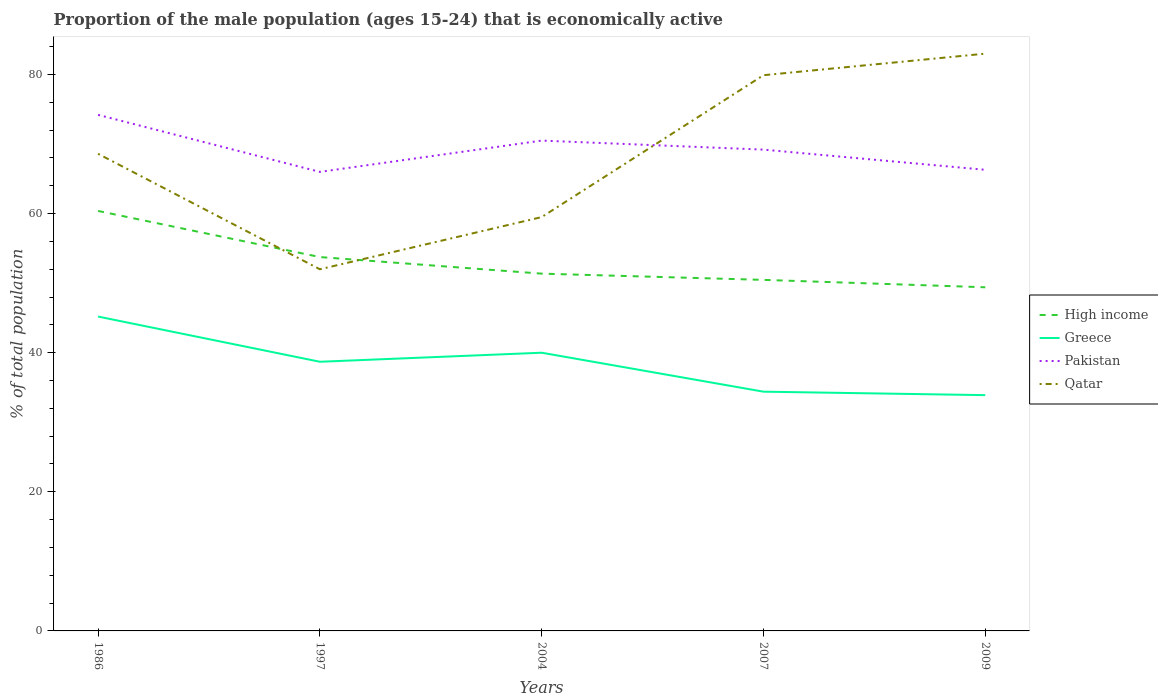Does the line corresponding to High income intersect with the line corresponding to Pakistan?
Provide a succinct answer. No. Is the number of lines equal to the number of legend labels?
Ensure brevity in your answer.  Yes. Across all years, what is the maximum proportion of the male population that is economically active in High income?
Your response must be concise. 49.41. What is the total proportion of the male population that is economically active in Greece in the graph?
Your answer should be very brief. 4.3. What is the difference between the highest and the second highest proportion of the male population that is economically active in Greece?
Your answer should be very brief. 11.3. Is the proportion of the male population that is economically active in Greece strictly greater than the proportion of the male population that is economically active in High income over the years?
Provide a short and direct response. Yes. What is the difference between two consecutive major ticks on the Y-axis?
Offer a terse response. 20. Are the values on the major ticks of Y-axis written in scientific E-notation?
Keep it short and to the point. No. Does the graph contain any zero values?
Offer a terse response. No. Does the graph contain grids?
Provide a succinct answer. No. Where does the legend appear in the graph?
Provide a short and direct response. Center right. What is the title of the graph?
Make the answer very short. Proportion of the male population (ages 15-24) that is economically active. What is the label or title of the X-axis?
Offer a very short reply. Years. What is the label or title of the Y-axis?
Offer a very short reply. % of total population. What is the % of total population in High income in 1986?
Offer a very short reply. 60.38. What is the % of total population of Greece in 1986?
Your answer should be very brief. 45.2. What is the % of total population of Pakistan in 1986?
Make the answer very short. 74.2. What is the % of total population of Qatar in 1986?
Provide a succinct answer. 68.6. What is the % of total population of High income in 1997?
Your response must be concise. 53.75. What is the % of total population in Greece in 1997?
Give a very brief answer. 38.7. What is the % of total population of High income in 2004?
Your answer should be very brief. 51.37. What is the % of total population of Greece in 2004?
Provide a succinct answer. 40. What is the % of total population in Pakistan in 2004?
Make the answer very short. 70.5. What is the % of total population of Qatar in 2004?
Your answer should be compact. 59.5. What is the % of total population in High income in 2007?
Offer a terse response. 50.47. What is the % of total population of Greece in 2007?
Make the answer very short. 34.4. What is the % of total population in Pakistan in 2007?
Offer a very short reply. 69.2. What is the % of total population in Qatar in 2007?
Your response must be concise. 79.9. What is the % of total population in High income in 2009?
Your answer should be compact. 49.41. What is the % of total population in Greece in 2009?
Your answer should be compact. 33.9. What is the % of total population in Pakistan in 2009?
Ensure brevity in your answer.  66.3. What is the % of total population of Qatar in 2009?
Make the answer very short. 83. Across all years, what is the maximum % of total population of High income?
Offer a terse response. 60.38. Across all years, what is the maximum % of total population in Greece?
Offer a very short reply. 45.2. Across all years, what is the maximum % of total population in Pakistan?
Your answer should be very brief. 74.2. Across all years, what is the maximum % of total population in Qatar?
Your answer should be compact. 83. Across all years, what is the minimum % of total population of High income?
Your answer should be very brief. 49.41. Across all years, what is the minimum % of total population of Greece?
Make the answer very short. 33.9. Across all years, what is the minimum % of total population of Pakistan?
Your answer should be compact. 66. What is the total % of total population in High income in the graph?
Your answer should be very brief. 265.39. What is the total % of total population of Greece in the graph?
Keep it short and to the point. 192.2. What is the total % of total population in Pakistan in the graph?
Make the answer very short. 346.2. What is the total % of total population of Qatar in the graph?
Give a very brief answer. 343. What is the difference between the % of total population of High income in 1986 and that in 1997?
Provide a short and direct response. 6.63. What is the difference between the % of total population in Pakistan in 1986 and that in 1997?
Offer a terse response. 8.2. What is the difference between the % of total population in High income in 1986 and that in 2004?
Offer a terse response. 9.02. What is the difference between the % of total population in Pakistan in 1986 and that in 2004?
Ensure brevity in your answer.  3.7. What is the difference between the % of total population in Qatar in 1986 and that in 2004?
Give a very brief answer. 9.1. What is the difference between the % of total population in High income in 1986 and that in 2007?
Ensure brevity in your answer.  9.91. What is the difference between the % of total population of Greece in 1986 and that in 2007?
Give a very brief answer. 10.8. What is the difference between the % of total population in Pakistan in 1986 and that in 2007?
Your answer should be compact. 5. What is the difference between the % of total population in High income in 1986 and that in 2009?
Your response must be concise. 10.98. What is the difference between the % of total population of Greece in 1986 and that in 2009?
Keep it short and to the point. 11.3. What is the difference between the % of total population of Pakistan in 1986 and that in 2009?
Offer a terse response. 7.9. What is the difference between the % of total population of Qatar in 1986 and that in 2009?
Provide a short and direct response. -14.4. What is the difference between the % of total population of High income in 1997 and that in 2004?
Ensure brevity in your answer.  2.38. What is the difference between the % of total population of High income in 1997 and that in 2007?
Offer a very short reply. 3.28. What is the difference between the % of total population of Greece in 1997 and that in 2007?
Give a very brief answer. 4.3. What is the difference between the % of total population in Qatar in 1997 and that in 2007?
Your answer should be compact. -27.9. What is the difference between the % of total population of High income in 1997 and that in 2009?
Make the answer very short. 4.34. What is the difference between the % of total population of Qatar in 1997 and that in 2009?
Make the answer very short. -31. What is the difference between the % of total population in High income in 2004 and that in 2007?
Offer a very short reply. 0.9. What is the difference between the % of total population in Greece in 2004 and that in 2007?
Your response must be concise. 5.6. What is the difference between the % of total population in Pakistan in 2004 and that in 2007?
Make the answer very short. 1.3. What is the difference between the % of total population in Qatar in 2004 and that in 2007?
Provide a short and direct response. -20.4. What is the difference between the % of total population in High income in 2004 and that in 2009?
Provide a short and direct response. 1.96. What is the difference between the % of total population in Greece in 2004 and that in 2009?
Keep it short and to the point. 6.1. What is the difference between the % of total population of Pakistan in 2004 and that in 2009?
Offer a very short reply. 4.2. What is the difference between the % of total population in Qatar in 2004 and that in 2009?
Your answer should be compact. -23.5. What is the difference between the % of total population of High income in 2007 and that in 2009?
Provide a short and direct response. 1.06. What is the difference between the % of total population in Pakistan in 2007 and that in 2009?
Offer a terse response. 2.9. What is the difference between the % of total population of Qatar in 2007 and that in 2009?
Give a very brief answer. -3.1. What is the difference between the % of total population in High income in 1986 and the % of total population in Greece in 1997?
Your response must be concise. 21.68. What is the difference between the % of total population in High income in 1986 and the % of total population in Pakistan in 1997?
Give a very brief answer. -5.62. What is the difference between the % of total population in High income in 1986 and the % of total population in Qatar in 1997?
Your response must be concise. 8.38. What is the difference between the % of total population of Greece in 1986 and the % of total population of Pakistan in 1997?
Give a very brief answer. -20.8. What is the difference between the % of total population of Pakistan in 1986 and the % of total population of Qatar in 1997?
Give a very brief answer. 22.2. What is the difference between the % of total population in High income in 1986 and the % of total population in Greece in 2004?
Your response must be concise. 20.38. What is the difference between the % of total population of High income in 1986 and the % of total population of Pakistan in 2004?
Your response must be concise. -10.12. What is the difference between the % of total population of High income in 1986 and the % of total population of Qatar in 2004?
Your response must be concise. 0.88. What is the difference between the % of total population of Greece in 1986 and the % of total population of Pakistan in 2004?
Offer a very short reply. -25.3. What is the difference between the % of total population of Greece in 1986 and the % of total population of Qatar in 2004?
Provide a succinct answer. -14.3. What is the difference between the % of total population in Pakistan in 1986 and the % of total population in Qatar in 2004?
Your response must be concise. 14.7. What is the difference between the % of total population of High income in 1986 and the % of total population of Greece in 2007?
Provide a short and direct response. 25.98. What is the difference between the % of total population of High income in 1986 and the % of total population of Pakistan in 2007?
Your answer should be very brief. -8.82. What is the difference between the % of total population of High income in 1986 and the % of total population of Qatar in 2007?
Your response must be concise. -19.52. What is the difference between the % of total population in Greece in 1986 and the % of total population in Qatar in 2007?
Offer a very short reply. -34.7. What is the difference between the % of total population of Pakistan in 1986 and the % of total population of Qatar in 2007?
Offer a terse response. -5.7. What is the difference between the % of total population of High income in 1986 and the % of total population of Greece in 2009?
Ensure brevity in your answer.  26.48. What is the difference between the % of total population of High income in 1986 and the % of total population of Pakistan in 2009?
Offer a very short reply. -5.92. What is the difference between the % of total population in High income in 1986 and the % of total population in Qatar in 2009?
Provide a succinct answer. -22.62. What is the difference between the % of total population in Greece in 1986 and the % of total population in Pakistan in 2009?
Offer a very short reply. -21.1. What is the difference between the % of total population in Greece in 1986 and the % of total population in Qatar in 2009?
Make the answer very short. -37.8. What is the difference between the % of total population of Pakistan in 1986 and the % of total population of Qatar in 2009?
Your answer should be very brief. -8.8. What is the difference between the % of total population of High income in 1997 and the % of total population of Greece in 2004?
Your answer should be very brief. 13.75. What is the difference between the % of total population in High income in 1997 and the % of total population in Pakistan in 2004?
Ensure brevity in your answer.  -16.75. What is the difference between the % of total population in High income in 1997 and the % of total population in Qatar in 2004?
Your answer should be compact. -5.75. What is the difference between the % of total population of Greece in 1997 and the % of total population of Pakistan in 2004?
Keep it short and to the point. -31.8. What is the difference between the % of total population in Greece in 1997 and the % of total population in Qatar in 2004?
Keep it short and to the point. -20.8. What is the difference between the % of total population of High income in 1997 and the % of total population of Greece in 2007?
Make the answer very short. 19.35. What is the difference between the % of total population in High income in 1997 and the % of total population in Pakistan in 2007?
Ensure brevity in your answer.  -15.45. What is the difference between the % of total population of High income in 1997 and the % of total population of Qatar in 2007?
Offer a very short reply. -26.15. What is the difference between the % of total population of Greece in 1997 and the % of total population of Pakistan in 2007?
Your answer should be very brief. -30.5. What is the difference between the % of total population in Greece in 1997 and the % of total population in Qatar in 2007?
Make the answer very short. -41.2. What is the difference between the % of total population in High income in 1997 and the % of total population in Greece in 2009?
Your answer should be compact. 19.85. What is the difference between the % of total population of High income in 1997 and the % of total population of Pakistan in 2009?
Ensure brevity in your answer.  -12.55. What is the difference between the % of total population in High income in 1997 and the % of total population in Qatar in 2009?
Your response must be concise. -29.25. What is the difference between the % of total population in Greece in 1997 and the % of total population in Pakistan in 2009?
Keep it short and to the point. -27.6. What is the difference between the % of total population in Greece in 1997 and the % of total population in Qatar in 2009?
Make the answer very short. -44.3. What is the difference between the % of total population of High income in 2004 and the % of total population of Greece in 2007?
Your response must be concise. 16.97. What is the difference between the % of total population of High income in 2004 and the % of total population of Pakistan in 2007?
Your response must be concise. -17.83. What is the difference between the % of total population in High income in 2004 and the % of total population in Qatar in 2007?
Provide a succinct answer. -28.53. What is the difference between the % of total population in Greece in 2004 and the % of total population in Pakistan in 2007?
Offer a terse response. -29.2. What is the difference between the % of total population in Greece in 2004 and the % of total population in Qatar in 2007?
Make the answer very short. -39.9. What is the difference between the % of total population in Pakistan in 2004 and the % of total population in Qatar in 2007?
Provide a succinct answer. -9.4. What is the difference between the % of total population in High income in 2004 and the % of total population in Greece in 2009?
Your answer should be very brief. 17.47. What is the difference between the % of total population in High income in 2004 and the % of total population in Pakistan in 2009?
Provide a succinct answer. -14.93. What is the difference between the % of total population of High income in 2004 and the % of total population of Qatar in 2009?
Offer a very short reply. -31.63. What is the difference between the % of total population of Greece in 2004 and the % of total population of Pakistan in 2009?
Offer a very short reply. -26.3. What is the difference between the % of total population of Greece in 2004 and the % of total population of Qatar in 2009?
Your answer should be very brief. -43. What is the difference between the % of total population in High income in 2007 and the % of total population in Greece in 2009?
Your answer should be very brief. 16.57. What is the difference between the % of total population of High income in 2007 and the % of total population of Pakistan in 2009?
Make the answer very short. -15.83. What is the difference between the % of total population in High income in 2007 and the % of total population in Qatar in 2009?
Give a very brief answer. -32.53. What is the difference between the % of total population in Greece in 2007 and the % of total population in Pakistan in 2009?
Offer a very short reply. -31.9. What is the difference between the % of total population in Greece in 2007 and the % of total population in Qatar in 2009?
Provide a short and direct response. -48.6. What is the difference between the % of total population in Pakistan in 2007 and the % of total population in Qatar in 2009?
Give a very brief answer. -13.8. What is the average % of total population of High income per year?
Make the answer very short. 53.08. What is the average % of total population of Greece per year?
Ensure brevity in your answer.  38.44. What is the average % of total population in Pakistan per year?
Provide a succinct answer. 69.24. What is the average % of total population of Qatar per year?
Keep it short and to the point. 68.6. In the year 1986, what is the difference between the % of total population in High income and % of total population in Greece?
Your response must be concise. 15.18. In the year 1986, what is the difference between the % of total population of High income and % of total population of Pakistan?
Your answer should be very brief. -13.82. In the year 1986, what is the difference between the % of total population in High income and % of total population in Qatar?
Offer a very short reply. -8.22. In the year 1986, what is the difference between the % of total population in Greece and % of total population in Pakistan?
Make the answer very short. -29. In the year 1986, what is the difference between the % of total population of Greece and % of total population of Qatar?
Keep it short and to the point. -23.4. In the year 1997, what is the difference between the % of total population in High income and % of total population in Greece?
Your answer should be very brief. 15.05. In the year 1997, what is the difference between the % of total population of High income and % of total population of Pakistan?
Provide a succinct answer. -12.25. In the year 1997, what is the difference between the % of total population in High income and % of total population in Qatar?
Offer a very short reply. 1.75. In the year 1997, what is the difference between the % of total population in Greece and % of total population in Pakistan?
Give a very brief answer. -27.3. In the year 1997, what is the difference between the % of total population of Greece and % of total population of Qatar?
Your response must be concise. -13.3. In the year 1997, what is the difference between the % of total population of Pakistan and % of total population of Qatar?
Provide a succinct answer. 14. In the year 2004, what is the difference between the % of total population of High income and % of total population of Greece?
Keep it short and to the point. 11.37. In the year 2004, what is the difference between the % of total population in High income and % of total population in Pakistan?
Make the answer very short. -19.13. In the year 2004, what is the difference between the % of total population of High income and % of total population of Qatar?
Your answer should be very brief. -8.13. In the year 2004, what is the difference between the % of total population of Greece and % of total population of Pakistan?
Offer a terse response. -30.5. In the year 2004, what is the difference between the % of total population of Greece and % of total population of Qatar?
Offer a very short reply. -19.5. In the year 2007, what is the difference between the % of total population of High income and % of total population of Greece?
Offer a very short reply. 16.07. In the year 2007, what is the difference between the % of total population of High income and % of total population of Pakistan?
Provide a short and direct response. -18.73. In the year 2007, what is the difference between the % of total population in High income and % of total population in Qatar?
Provide a short and direct response. -29.43. In the year 2007, what is the difference between the % of total population of Greece and % of total population of Pakistan?
Your answer should be very brief. -34.8. In the year 2007, what is the difference between the % of total population in Greece and % of total population in Qatar?
Make the answer very short. -45.5. In the year 2007, what is the difference between the % of total population of Pakistan and % of total population of Qatar?
Your response must be concise. -10.7. In the year 2009, what is the difference between the % of total population of High income and % of total population of Greece?
Ensure brevity in your answer.  15.51. In the year 2009, what is the difference between the % of total population in High income and % of total population in Pakistan?
Make the answer very short. -16.89. In the year 2009, what is the difference between the % of total population in High income and % of total population in Qatar?
Provide a succinct answer. -33.59. In the year 2009, what is the difference between the % of total population of Greece and % of total population of Pakistan?
Your response must be concise. -32.4. In the year 2009, what is the difference between the % of total population of Greece and % of total population of Qatar?
Ensure brevity in your answer.  -49.1. In the year 2009, what is the difference between the % of total population of Pakistan and % of total population of Qatar?
Keep it short and to the point. -16.7. What is the ratio of the % of total population of High income in 1986 to that in 1997?
Your response must be concise. 1.12. What is the ratio of the % of total population of Greece in 1986 to that in 1997?
Provide a short and direct response. 1.17. What is the ratio of the % of total population of Pakistan in 1986 to that in 1997?
Provide a succinct answer. 1.12. What is the ratio of the % of total population in Qatar in 1986 to that in 1997?
Offer a very short reply. 1.32. What is the ratio of the % of total population of High income in 1986 to that in 2004?
Provide a succinct answer. 1.18. What is the ratio of the % of total population in Greece in 1986 to that in 2004?
Provide a succinct answer. 1.13. What is the ratio of the % of total population of Pakistan in 1986 to that in 2004?
Offer a very short reply. 1.05. What is the ratio of the % of total population in Qatar in 1986 to that in 2004?
Your answer should be compact. 1.15. What is the ratio of the % of total population of High income in 1986 to that in 2007?
Your answer should be very brief. 1.2. What is the ratio of the % of total population of Greece in 1986 to that in 2007?
Keep it short and to the point. 1.31. What is the ratio of the % of total population of Pakistan in 1986 to that in 2007?
Offer a terse response. 1.07. What is the ratio of the % of total population of Qatar in 1986 to that in 2007?
Your answer should be very brief. 0.86. What is the ratio of the % of total population in High income in 1986 to that in 2009?
Make the answer very short. 1.22. What is the ratio of the % of total population of Pakistan in 1986 to that in 2009?
Keep it short and to the point. 1.12. What is the ratio of the % of total population in Qatar in 1986 to that in 2009?
Your answer should be compact. 0.83. What is the ratio of the % of total population of High income in 1997 to that in 2004?
Your answer should be compact. 1.05. What is the ratio of the % of total population of Greece in 1997 to that in 2004?
Make the answer very short. 0.97. What is the ratio of the % of total population of Pakistan in 1997 to that in 2004?
Your response must be concise. 0.94. What is the ratio of the % of total population of Qatar in 1997 to that in 2004?
Provide a short and direct response. 0.87. What is the ratio of the % of total population of High income in 1997 to that in 2007?
Give a very brief answer. 1.06. What is the ratio of the % of total population in Pakistan in 1997 to that in 2007?
Offer a terse response. 0.95. What is the ratio of the % of total population of Qatar in 1997 to that in 2007?
Give a very brief answer. 0.65. What is the ratio of the % of total population in High income in 1997 to that in 2009?
Your answer should be compact. 1.09. What is the ratio of the % of total population in Greece in 1997 to that in 2009?
Give a very brief answer. 1.14. What is the ratio of the % of total population of Pakistan in 1997 to that in 2009?
Make the answer very short. 1. What is the ratio of the % of total population of Qatar in 1997 to that in 2009?
Ensure brevity in your answer.  0.63. What is the ratio of the % of total population in High income in 2004 to that in 2007?
Give a very brief answer. 1.02. What is the ratio of the % of total population of Greece in 2004 to that in 2007?
Your response must be concise. 1.16. What is the ratio of the % of total population in Pakistan in 2004 to that in 2007?
Your answer should be compact. 1.02. What is the ratio of the % of total population in Qatar in 2004 to that in 2007?
Your answer should be compact. 0.74. What is the ratio of the % of total population in High income in 2004 to that in 2009?
Keep it short and to the point. 1.04. What is the ratio of the % of total population of Greece in 2004 to that in 2009?
Offer a very short reply. 1.18. What is the ratio of the % of total population of Pakistan in 2004 to that in 2009?
Provide a short and direct response. 1.06. What is the ratio of the % of total population of Qatar in 2004 to that in 2009?
Provide a short and direct response. 0.72. What is the ratio of the % of total population of High income in 2007 to that in 2009?
Ensure brevity in your answer.  1.02. What is the ratio of the % of total population of Greece in 2007 to that in 2009?
Your answer should be compact. 1.01. What is the ratio of the % of total population in Pakistan in 2007 to that in 2009?
Your answer should be compact. 1.04. What is the ratio of the % of total population in Qatar in 2007 to that in 2009?
Your answer should be very brief. 0.96. What is the difference between the highest and the second highest % of total population of High income?
Provide a short and direct response. 6.63. What is the difference between the highest and the second highest % of total population of Pakistan?
Offer a very short reply. 3.7. What is the difference between the highest and the second highest % of total population of Qatar?
Ensure brevity in your answer.  3.1. What is the difference between the highest and the lowest % of total population in High income?
Provide a succinct answer. 10.98. What is the difference between the highest and the lowest % of total population of Pakistan?
Keep it short and to the point. 8.2. What is the difference between the highest and the lowest % of total population of Qatar?
Your response must be concise. 31. 